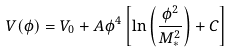<formula> <loc_0><loc_0><loc_500><loc_500>V ( \phi ) = V _ { 0 } + A \phi ^ { 4 } \left [ \ln \left ( \frac { \phi ^ { 2 } } { M _ { * } ^ { 2 } } \right ) + C \right ]</formula> 